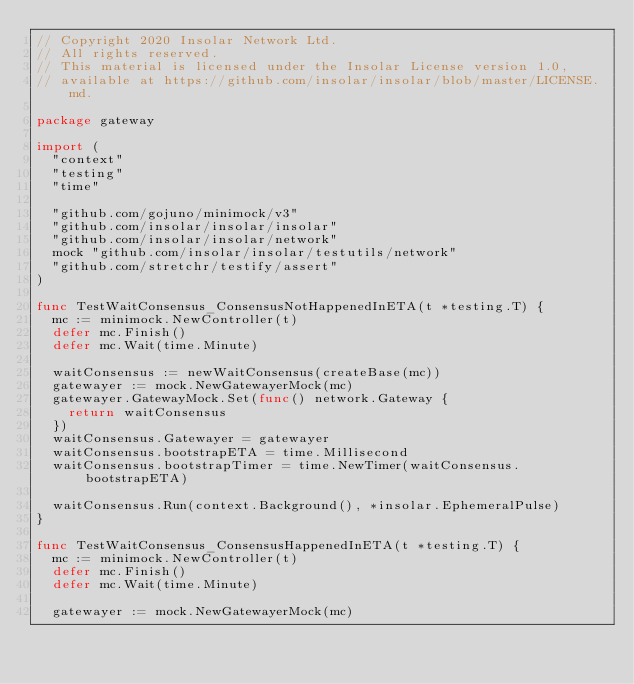Convert code to text. <code><loc_0><loc_0><loc_500><loc_500><_Go_>// Copyright 2020 Insolar Network Ltd.
// All rights reserved.
// This material is licensed under the Insolar License version 1.0,
// available at https://github.com/insolar/insolar/blob/master/LICENSE.md.

package gateway

import (
	"context"
	"testing"
	"time"

	"github.com/gojuno/minimock/v3"
	"github.com/insolar/insolar/insolar"
	"github.com/insolar/insolar/network"
	mock "github.com/insolar/insolar/testutils/network"
	"github.com/stretchr/testify/assert"
)

func TestWaitConsensus_ConsensusNotHappenedInETA(t *testing.T) {
	mc := minimock.NewController(t)
	defer mc.Finish()
	defer mc.Wait(time.Minute)

	waitConsensus := newWaitConsensus(createBase(mc))
	gatewayer := mock.NewGatewayerMock(mc)
	gatewayer.GatewayMock.Set(func() network.Gateway {
		return waitConsensus
	})
	waitConsensus.Gatewayer = gatewayer
	waitConsensus.bootstrapETA = time.Millisecond
	waitConsensus.bootstrapTimer = time.NewTimer(waitConsensus.bootstrapETA)

	waitConsensus.Run(context.Background(), *insolar.EphemeralPulse)
}

func TestWaitConsensus_ConsensusHappenedInETA(t *testing.T) {
	mc := minimock.NewController(t)
	defer mc.Finish()
	defer mc.Wait(time.Minute)

	gatewayer := mock.NewGatewayerMock(mc)</code> 